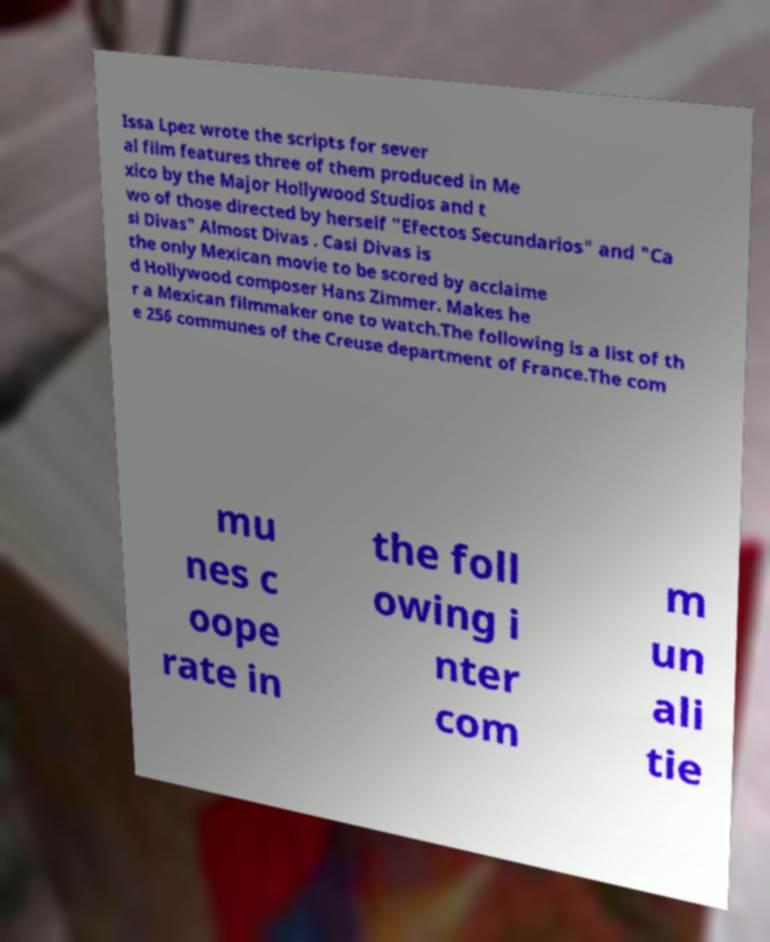There's text embedded in this image that I need extracted. Can you transcribe it verbatim? Issa Lpez wrote the scripts for sever al film features three of them produced in Me xico by the Major Hollywood Studios and t wo of those directed by herself "Efectos Secundarios" and "Ca si Divas" Almost Divas . Casi Divas is the only Mexican movie to be scored by acclaime d Hollywood composer Hans Zimmer. Makes he r a Mexican filmmaker one to watch.The following is a list of th e 256 communes of the Creuse department of France.The com mu nes c oope rate in the foll owing i nter com m un ali tie 